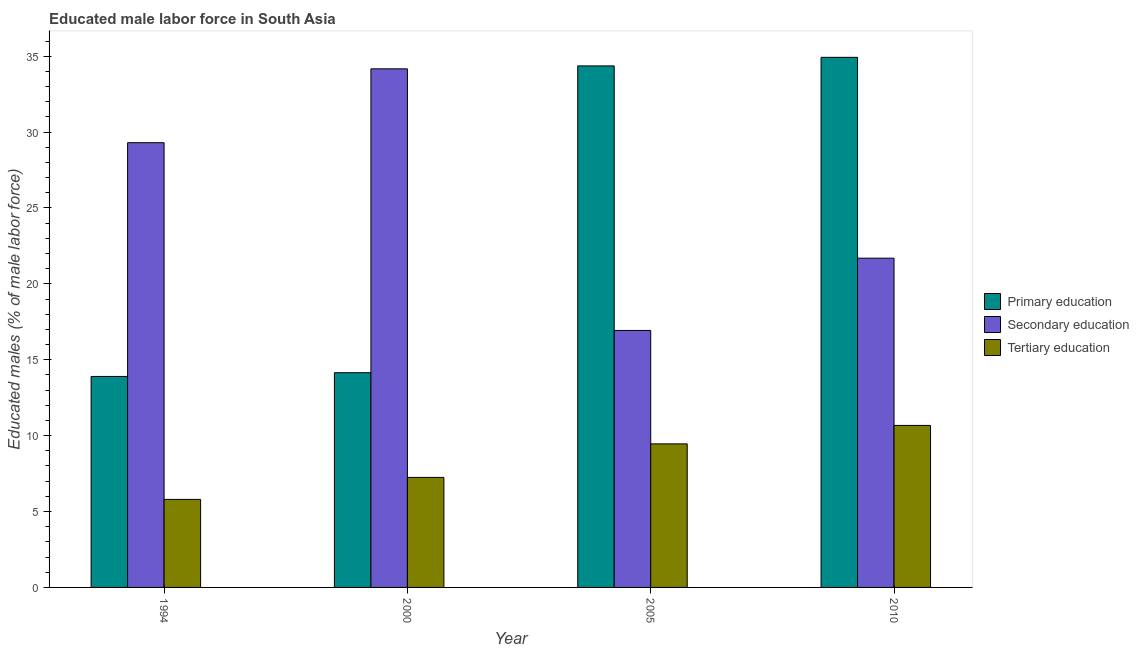How many different coloured bars are there?
Keep it short and to the point. 3. How many groups of bars are there?
Offer a very short reply. 4. Are the number of bars per tick equal to the number of legend labels?
Ensure brevity in your answer.  Yes. What is the label of the 1st group of bars from the left?
Ensure brevity in your answer.  1994. In how many cases, is the number of bars for a given year not equal to the number of legend labels?
Your response must be concise. 0. What is the percentage of male labor force who received primary education in 2000?
Your response must be concise. 14.15. Across all years, what is the maximum percentage of male labor force who received secondary education?
Your response must be concise. 34.17. Across all years, what is the minimum percentage of male labor force who received secondary education?
Ensure brevity in your answer.  16.93. What is the total percentage of male labor force who received primary education in the graph?
Give a very brief answer. 97.33. What is the difference between the percentage of male labor force who received primary education in 2000 and that in 2010?
Your answer should be compact. -20.78. What is the difference between the percentage of male labor force who received secondary education in 2000 and the percentage of male labor force who received tertiary education in 1994?
Provide a succinct answer. 4.87. What is the average percentage of male labor force who received primary education per year?
Provide a short and direct response. 24.33. In the year 1994, what is the difference between the percentage of male labor force who received tertiary education and percentage of male labor force who received primary education?
Provide a succinct answer. 0. What is the ratio of the percentage of male labor force who received secondary education in 2000 to that in 2005?
Your answer should be very brief. 2.02. What is the difference between the highest and the second highest percentage of male labor force who received tertiary education?
Offer a terse response. 1.22. What is the difference between the highest and the lowest percentage of male labor force who received tertiary education?
Your response must be concise. 4.87. In how many years, is the percentage of male labor force who received tertiary education greater than the average percentage of male labor force who received tertiary education taken over all years?
Offer a very short reply. 2. Is the sum of the percentage of male labor force who received primary education in 2005 and 2010 greater than the maximum percentage of male labor force who received tertiary education across all years?
Ensure brevity in your answer.  Yes. What does the 1st bar from the right in 2000 represents?
Keep it short and to the point. Tertiary education. Are all the bars in the graph horizontal?
Your answer should be compact. No. How many years are there in the graph?
Keep it short and to the point. 4. What is the difference between two consecutive major ticks on the Y-axis?
Make the answer very short. 5. Does the graph contain any zero values?
Provide a short and direct response. No. How many legend labels are there?
Offer a terse response. 3. How are the legend labels stacked?
Keep it short and to the point. Vertical. What is the title of the graph?
Ensure brevity in your answer.  Educated male labor force in South Asia. What is the label or title of the X-axis?
Give a very brief answer. Year. What is the label or title of the Y-axis?
Ensure brevity in your answer.  Educated males (% of male labor force). What is the Educated males (% of male labor force) of Primary education in 1994?
Ensure brevity in your answer.  13.9. What is the Educated males (% of male labor force) of Secondary education in 1994?
Ensure brevity in your answer.  29.3. What is the Educated males (% of male labor force) in Tertiary education in 1994?
Provide a succinct answer. 5.8. What is the Educated males (% of male labor force) in Primary education in 2000?
Offer a very short reply. 14.15. What is the Educated males (% of male labor force) in Secondary education in 2000?
Provide a succinct answer. 34.17. What is the Educated males (% of male labor force) in Tertiary education in 2000?
Your answer should be very brief. 7.25. What is the Educated males (% of male labor force) in Primary education in 2005?
Your response must be concise. 34.36. What is the Educated males (% of male labor force) in Secondary education in 2005?
Ensure brevity in your answer.  16.93. What is the Educated males (% of male labor force) in Tertiary education in 2005?
Provide a short and direct response. 9.46. What is the Educated males (% of male labor force) in Primary education in 2010?
Make the answer very short. 34.92. What is the Educated males (% of male labor force) in Secondary education in 2010?
Provide a succinct answer. 21.69. What is the Educated males (% of male labor force) in Tertiary education in 2010?
Keep it short and to the point. 10.67. Across all years, what is the maximum Educated males (% of male labor force) of Primary education?
Offer a very short reply. 34.92. Across all years, what is the maximum Educated males (% of male labor force) in Secondary education?
Ensure brevity in your answer.  34.17. Across all years, what is the maximum Educated males (% of male labor force) of Tertiary education?
Your response must be concise. 10.67. Across all years, what is the minimum Educated males (% of male labor force) in Primary education?
Provide a short and direct response. 13.9. Across all years, what is the minimum Educated males (% of male labor force) of Secondary education?
Your response must be concise. 16.93. Across all years, what is the minimum Educated males (% of male labor force) of Tertiary education?
Provide a succinct answer. 5.8. What is the total Educated males (% of male labor force) of Primary education in the graph?
Give a very brief answer. 97.33. What is the total Educated males (% of male labor force) of Secondary education in the graph?
Your answer should be compact. 102.09. What is the total Educated males (% of male labor force) in Tertiary education in the graph?
Make the answer very short. 33.18. What is the difference between the Educated males (% of male labor force) of Primary education in 1994 and that in 2000?
Your answer should be compact. -0.25. What is the difference between the Educated males (% of male labor force) of Secondary education in 1994 and that in 2000?
Your answer should be compact. -4.87. What is the difference between the Educated males (% of male labor force) in Tertiary education in 1994 and that in 2000?
Provide a succinct answer. -1.45. What is the difference between the Educated males (% of male labor force) in Primary education in 1994 and that in 2005?
Your response must be concise. -20.46. What is the difference between the Educated males (% of male labor force) of Secondary education in 1994 and that in 2005?
Keep it short and to the point. 12.37. What is the difference between the Educated males (% of male labor force) of Tertiary education in 1994 and that in 2005?
Your answer should be compact. -3.66. What is the difference between the Educated males (% of male labor force) in Primary education in 1994 and that in 2010?
Provide a short and direct response. -21.02. What is the difference between the Educated males (% of male labor force) of Secondary education in 1994 and that in 2010?
Offer a terse response. 7.61. What is the difference between the Educated males (% of male labor force) in Tertiary education in 1994 and that in 2010?
Give a very brief answer. -4.87. What is the difference between the Educated males (% of male labor force) in Primary education in 2000 and that in 2005?
Provide a succinct answer. -20.21. What is the difference between the Educated males (% of male labor force) of Secondary education in 2000 and that in 2005?
Your response must be concise. 17.24. What is the difference between the Educated males (% of male labor force) of Tertiary education in 2000 and that in 2005?
Make the answer very short. -2.21. What is the difference between the Educated males (% of male labor force) of Primary education in 2000 and that in 2010?
Keep it short and to the point. -20.78. What is the difference between the Educated males (% of male labor force) in Secondary education in 2000 and that in 2010?
Offer a very short reply. 12.48. What is the difference between the Educated males (% of male labor force) of Tertiary education in 2000 and that in 2010?
Keep it short and to the point. -3.43. What is the difference between the Educated males (% of male labor force) in Primary education in 2005 and that in 2010?
Give a very brief answer. -0.56. What is the difference between the Educated males (% of male labor force) in Secondary education in 2005 and that in 2010?
Give a very brief answer. -4.76. What is the difference between the Educated males (% of male labor force) of Tertiary education in 2005 and that in 2010?
Offer a very short reply. -1.22. What is the difference between the Educated males (% of male labor force) of Primary education in 1994 and the Educated males (% of male labor force) of Secondary education in 2000?
Provide a succinct answer. -20.27. What is the difference between the Educated males (% of male labor force) in Primary education in 1994 and the Educated males (% of male labor force) in Tertiary education in 2000?
Offer a terse response. 6.65. What is the difference between the Educated males (% of male labor force) of Secondary education in 1994 and the Educated males (% of male labor force) of Tertiary education in 2000?
Give a very brief answer. 22.05. What is the difference between the Educated males (% of male labor force) of Primary education in 1994 and the Educated males (% of male labor force) of Secondary education in 2005?
Provide a short and direct response. -3.03. What is the difference between the Educated males (% of male labor force) in Primary education in 1994 and the Educated males (% of male labor force) in Tertiary education in 2005?
Give a very brief answer. 4.44. What is the difference between the Educated males (% of male labor force) in Secondary education in 1994 and the Educated males (% of male labor force) in Tertiary education in 2005?
Your answer should be very brief. 19.84. What is the difference between the Educated males (% of male labor force) of Primary education in 1994 and the Educated males (% of male labor force) of Secondary education in 2010?
Ensure brevity in your answer.  -7.79. What is the difference between the Educated males (% of male labor force) of Primary education in 1994 and the Educated males (% of male labor force) of Tertiary education in 2010?
Provide a short and direct response. 3.23. What is the difference between the Educated males (% of male labor force) of Secondary education in 1994 and the Educated males (% of male labor force) of Tertiary education in 2010?
Provide a succinct answer. 18.63. What is the difference between the Educated males (% of male labor force) in Primary education in 2000 and the Educated males (% of male labor force) in Secondary education in 2005?
Ensure brevity in your answer.  -2.78. What is the difference between the Educated males (% of male labor force) in Primary education in 2000 and the Educated males (% of male labor force) in Tertiary education in 2005?
Make the answer very short. 4.69. What is the difference between the Educated males (% of male labor force) of Secondary education in 2000 and the Educated males (% of male labor force) of Tertiary education in 2005?
Provide a short and direct response. 24.71. What is the difference between the Educated males (% of male labor force) in Primary education in 2000 and the Educated males (% of male labor force) in Secondary education in 2010?
Your answer should be very brief. -7.54. What is the difference between the Educated males (% of male labor force) in Primary education in 2000 and the Educated males (% of male labor force) in Tertiary education in 2010?
Offer a very short reply. 3.47. What is the difference between the Educated males (% of male labor force) in Secondary education in 2000 and the Educated males (% of male labor force) in Tertiary education in 2010?
Make the answer very short. 23.49. What is the difference between the Educated males (% of male labor force) in Primary education in 2005 and the Educated males (% of male labor force) in Secondary education in 2010?
Offer a terse response. 12.67. What is the difference between the Educated males (% of male labor force) of Primary education in 2005 and the Educated males (% of male labor force) of Tertiary education in 2010?
Provide a short and direct response. 23.69. What is the difference between the Educated males (% of male labor force) of Secondary education in 2005 and the Educated males (% of male labor force) of Tertiary education in 2010?
Keep it short and to the point. 6.26. What is the average Educated males (% of male labor force) of Primary education per year?
Give a very brief answer. 24.33. What is the average Educated males (% of male labor force) in Secondary education per year?
Your answer should be very brief. 25.52. What is the average Educated males (% of male labor force) of Tertiary education per year?
Make the answer very short. 8.3. In the year 1994, what is the difference between the Educated males (% of male labor force) in Primary education and Educated males (% of male labor force) in Secondary education?
Your response must be concise. -15.4. In the year 1994, what is the difference between the Educated males (% of male labor force) in Primary education and Educated males (% of male labor force) in Tertiary education?
Offer a terse response. 8.1. In the year 1994, what is the difference between the Educated males (% of male labor force) in Secondary education and Educated males (% of male labor force) in Tertiary education?
Your response must be concise. 23.5. In the year 2000, what is the difference between the Educated males (% of male labor force) in Primary education and Educated males (% of male labor force) in Secondary education?
Make the answer very short. -20.02. In the year 2000, what is the difference between the Educated males (% of male labor force) of Primary education and Educated males (% of male labor force) of Tertiary education?
Your answer should be very brief. 6.9. In the year 2000, what is the difference between the Educated males (% of male labor force) in Secondary education and Educated males (% of male labor force) in Tertiary education?
Your answer should be compact. 26.92. In the year 2005, what is the difference between the Educated males (% of male labor force) in Primary education and Educated males (% of male labor force) in Secondary education?
Keep it short and to the point. 17.43. In the year 2005, what is the difference between the Educated males (% of male labor force) in Primary education and Educated males (% of male labor force) in Tertiary education?
Offer a terse response. 24.9. In the year 2005, what is the difference between the Educated males (% of male labor force) in Secondary education and Educated males (% of male labor force) in Tertiary education?
Ensure brevity in your answer.  7.47. In the year 2010, what is the difference between the Educated males (% of male labor force) of Primary education and Educated males (% of male labor force) of Secondary education?
Offer a very short reply. 13.23. In the year 2010, what is the difference between the Educated males (% of male labor force) of Primary education and Educated males (% of male labor force) of Tertiary education?
Ensure brevity in your answer.  24.25. In the year 2010, what is the difference between the Educated males (% of male labor force) of Secondary education and Educated males (% of male labor force) of Tertiary education?
Your response must be concise. 11.02. What is the ratio of the Educated males (% of male labor force) of Primary education in 1994 to that in 2000?
Keep it short and to the point. 0.98. What is the ratio of the Educated males (% of male labor force) of Secondary education in 1994 to that in 2000?
Give a very brief answer. 0.86. What is the ratio of the Educated males (% of male labor force) in Tertiary education in 1994 to that in 2000?
Provide a short and direct response. 0.8. What is the ratio of the Educated males (% of male labor force) of Primary education in 1994 to that in 2005?
Provide a short and direct response. 0.4. What is the ratio of the Educated males (% of male labor force) in Secondary education in 1994 to that in 2005?
Make the answer very short. 1.73. What is the ratio of the Educated males (% of male labor force) of Tertiary education in 1994 to that in 2005?
Ensure brevity in your answer.  0.61. What is the ratio of the Educated males (% of male labor force) of Primary education in 1994 to that in 2010?
Provide a succinct answer. 0.4. What is the ratio of the Educated males (% of male labor force) in Secondary education in 1994 to that in 2010?
Ensure brevity in your answer.  1.35. What is the ratio of the Educated males (% of male labor force) in Tertiary education in 1994 to that in 2010?
Keep it short and to the point. 0.54. What is the ratio of the Educated males (% of male labor force) in Primary education in 2000 to that in 2005?
Provide a short and direct response. 0.41. What is the ratio of the Educated males (% of male labor force) of Secondary education in 2000 to that in 2005?
Keep it short and to the point. 2.02. What is the ratio of the Educated males (% of male labor force) of Tertiary education in 2000 to that in 2005?
Your response must be concise. 0.77. What is the ratio of the Educated males (% of male labor force) in Primary education in 2000 to that in 2010?
Provide a succinct answer. 0.41. What is the ratio of the Educated males (% of male labor force) of Secondary education in 2000 to that in 2010?
Give a very brief answer. 1.58. What is the ratio of the Educated males (% of male labor force) of Tertiary education in 2000 to that in 2010?
Keep it short and to the point. 0.68. What is the ratio of the Educated males (% of male labor force) in Primary education in 2005 to that in 2010?
Ensure brevity in your answer.  0.98. What is the ratio of the Educated males (% of male labor force) in Secondary education in 2005 to that in 2010?
Your answer should be very brief. 0.78. What is the ratio of the Educated males (% of male labor force) in Tertiary education in 2005 to that in 2010?
Ensure brevity in your answer.  0.89. What is the difference between the highest and the second highest Educated males (% of male labor force) in Primary education?
Make the answer very short. 0.56. What is the difference between the highest and the second highest Educated males (% of male labor force) in Secondary education?
Give a very brief answer. 4.87. What is the difference between the highest and the second highest Educated males (% of male labor force) in Tertiary education?
Provide a succinct answer. 1.22. What is the difference between the highest and the lowest Educated males (% of male labor force) of Primary education?
Offer a very short reply. 21.02. What is the difference between the highest and the lowest Educated males (% of male labor force) in Secondary education?
Provide a succinct answer. 17.24. What is the difference between the highest and the lowest Educated males (% of male labor force) in Tertiary education?
Offer a very short reply. 4.87. 